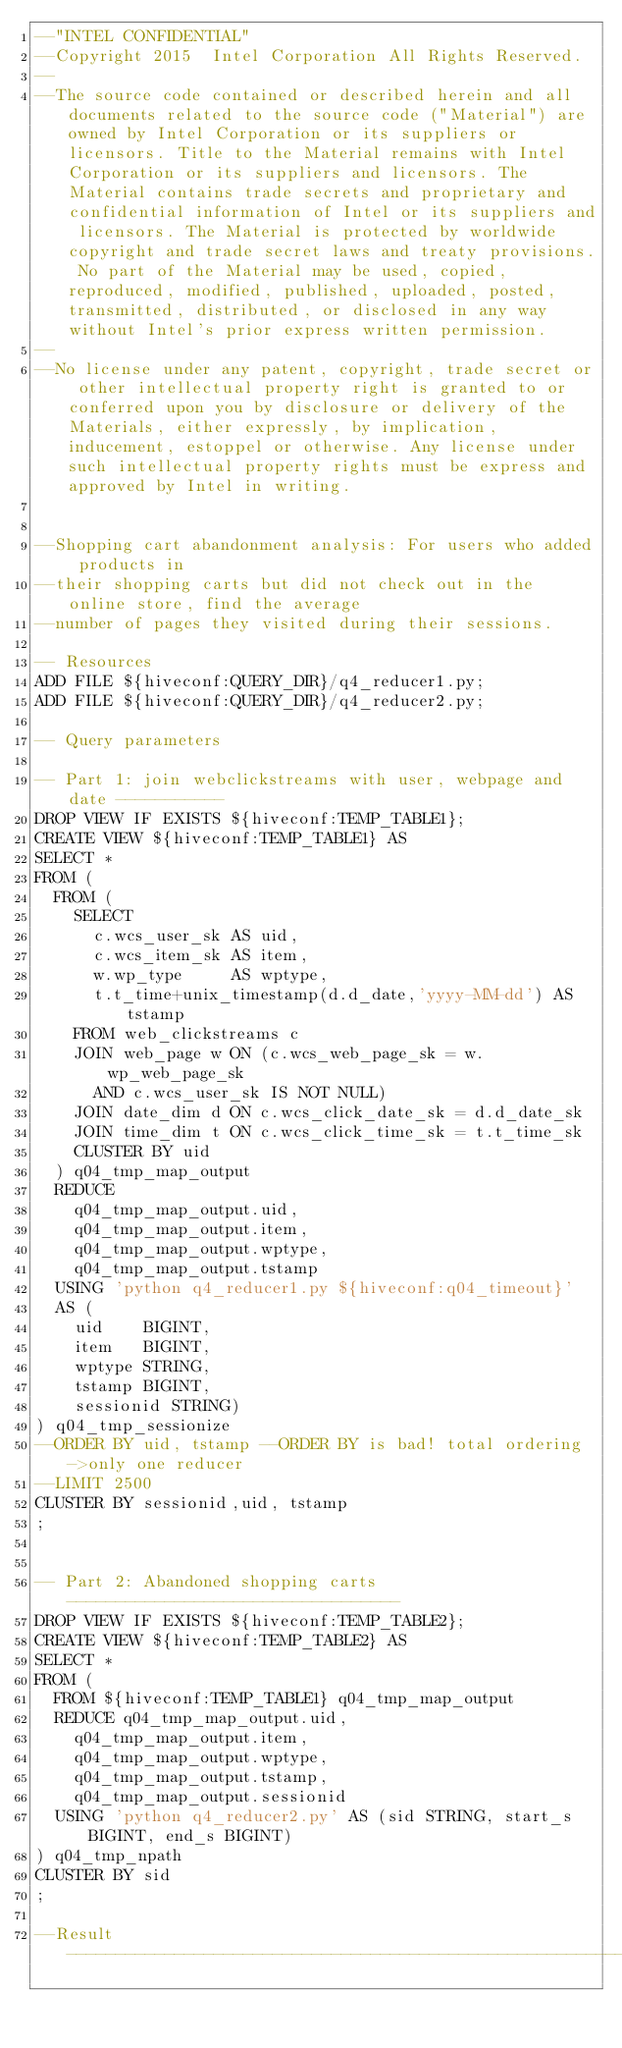<code> <loc_0><loc_0><loc_500><loc_500><_SQL_>--"INTEL CONFIDENTIAL"
--Copyright 2015  Intel Corporation All Rights Reserved.
--
--The source code contained or described herein and all documents related to the source code ("Material") are owned by Intel Corporation or its suppliers or licensors. Title to the Material remains with Intel Corporation or its suppliers and licensors. The Material contains trade secrets and proprietary and confidential information of Intel or its suppliers and licensors. The Material is protected by worldwide copyright and trade secret laws and treaty provisions. No part of the Material may be used, copied, reproduced, modified, published, uploaded, posted, transmitted, distributed, or disclosed in any way without Intel's prior express written permission.
--
--No license under any patent, copyright, trade secret or other intellectual property right is granted to or conferred upon you by disclosure or delivery of the Materials, either expressly, by implication, inducement, estoppel or otherwise. Any license under such intellectual property rights must be express and approved by Intel in writing.


--Shopping cart abandonment analysis: For users who added products in
--their shopping carts but did not check out in the online store, find the average
--number of pages they visited during their sessions.

-- Resources
ADD FILE ${hiveconf:QUERY_DIR}/q4_reducer1.py;
ADD FILE ${hiveconf:QUERY_DIR}/q4_reducer2.py;

-- Query parameters

-- Part 1: join webclickstreams with user, webpage and date -----------
DROP VIEW IF EXISTS ${hiveconf:TEMP_TABLE1};
CREATE VIEW ${hiveconf:TEMP_TABLE1} AS
SELECT *
FROM (
  FROM (
    SELECT
      c.wcs_user_sk AS uid,
      c.wcs_item_sk AS item,
      w.wp_type     AS wptype,
      t.t_time+unix_timestamp(d.d_date,'yyyy-MM-dd') AS tstamp
    FROM web_clickstreams c
    JOIN web_page w ON (c.wcs_web_page_sk = w.wp_web_page_sk
      AND c.wcs_user_sk IS NOT NULL)
    JOIN date_dim d ON c.wcs_click_date_sk = d.d_date_sk
    JOIN time_dim t ON c.wcs_click_time_sk = t.t_time_sk
    CLUSTER BY uid
  ) q04_tmp_map_output
  REDUCE
    q04_tmp_map_output.uid,
    q04_tmp_map_output.item,
    q04_tmp_map_output.wptype,
    q04_tmp_map_output.tstamp
  USING 'python q4_reducer1.py ${hiveconf:q04_timeout}'
  AS (
    uid    BIGINT,
    item   BIGINT,
    wptype STRING,
    tstamp BIGINT,
    sessionid STRING)
) q04_tmp_sessionize
--ORDER BY uid, tstamp --ORDER BY is bad! total ordering ->only one reducer
--LIMIT 2500
CLUSTER BY sessionid,uid, tstamp
;


-- Part 2: Abandoned shopping carts ----------------------------------
DROP VIEW IF EXISTS ${hiveconf:TEMP_TABLE2};
CREATE VIEW ${hiveconf:TEMP_TABLE2} AS
SELECT *
FROM (
  FROM ${hiveconf:TEMP_TABLE1} q04_tmp_map_output
  REDUCE q04_tmp_map_output.uid,
    q04_tmp_map_output.item,
    q04_tmp_map_output.wptype,
    q04_tmp_map_output.tstamp,
    q04_tmp_map_output.sessionid
  USING 'python q4_reducer2.py' AS (sid STRING, start_s BIGINT, end_s BIGINT)
) q04_tmp_npath
CLUSTER BY sid
;

--Result  --------------------------------------------------------------------</code> 